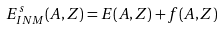Convert formula to latex. <formula><loc_0><loc_0><loc_500><loc_500>E ^ { s } _ { I N M } ( A , Z ) = E ( A , Z ) + f ( A , Z )</formula> 